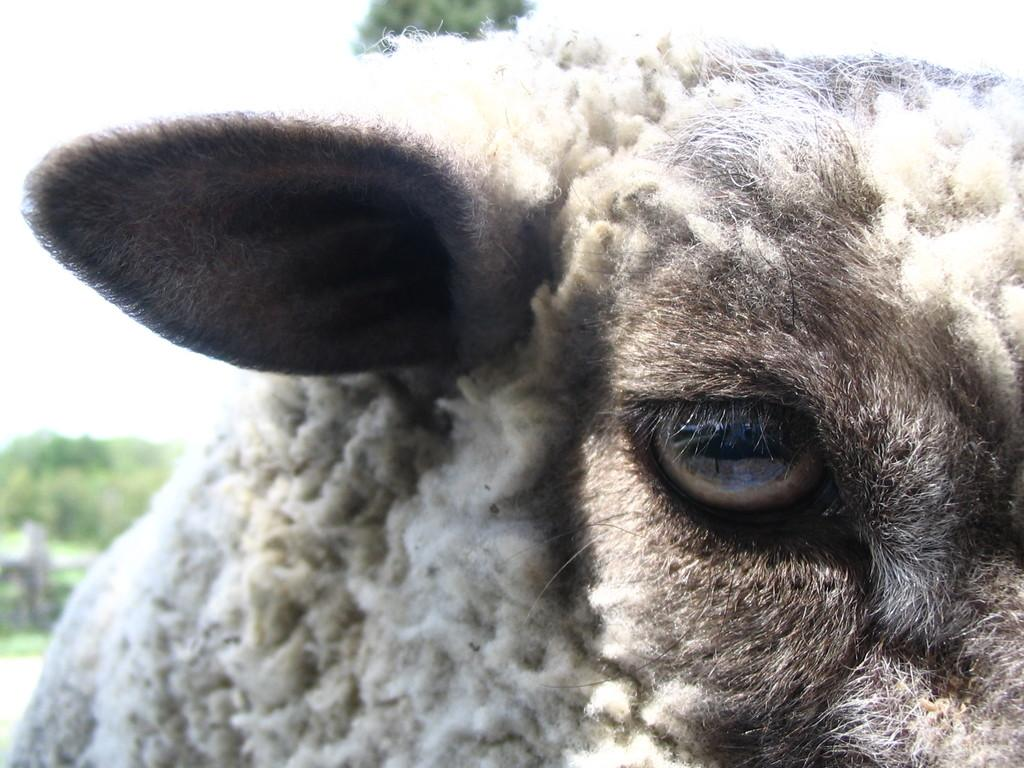What is the main subject in the front of the image? There is a white color sheep in the front of the image. What can be seen in the background of the image? There are trees in the background of the image. What decision does the sheep make in the image? There is no indication in the image that the sheep is making any decisions. 